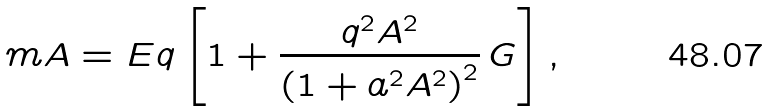<formula> <loc_0><loc_0><loc_500><loc_500>m A = E q \left [ 1 + \frac { q ^ { 2 } A ^ { 2 } } { \left ( 1 + a ^ { 2 } A ^ { 2 } \right ) ^ { 2 } } \, G \right ] ,</formula> 